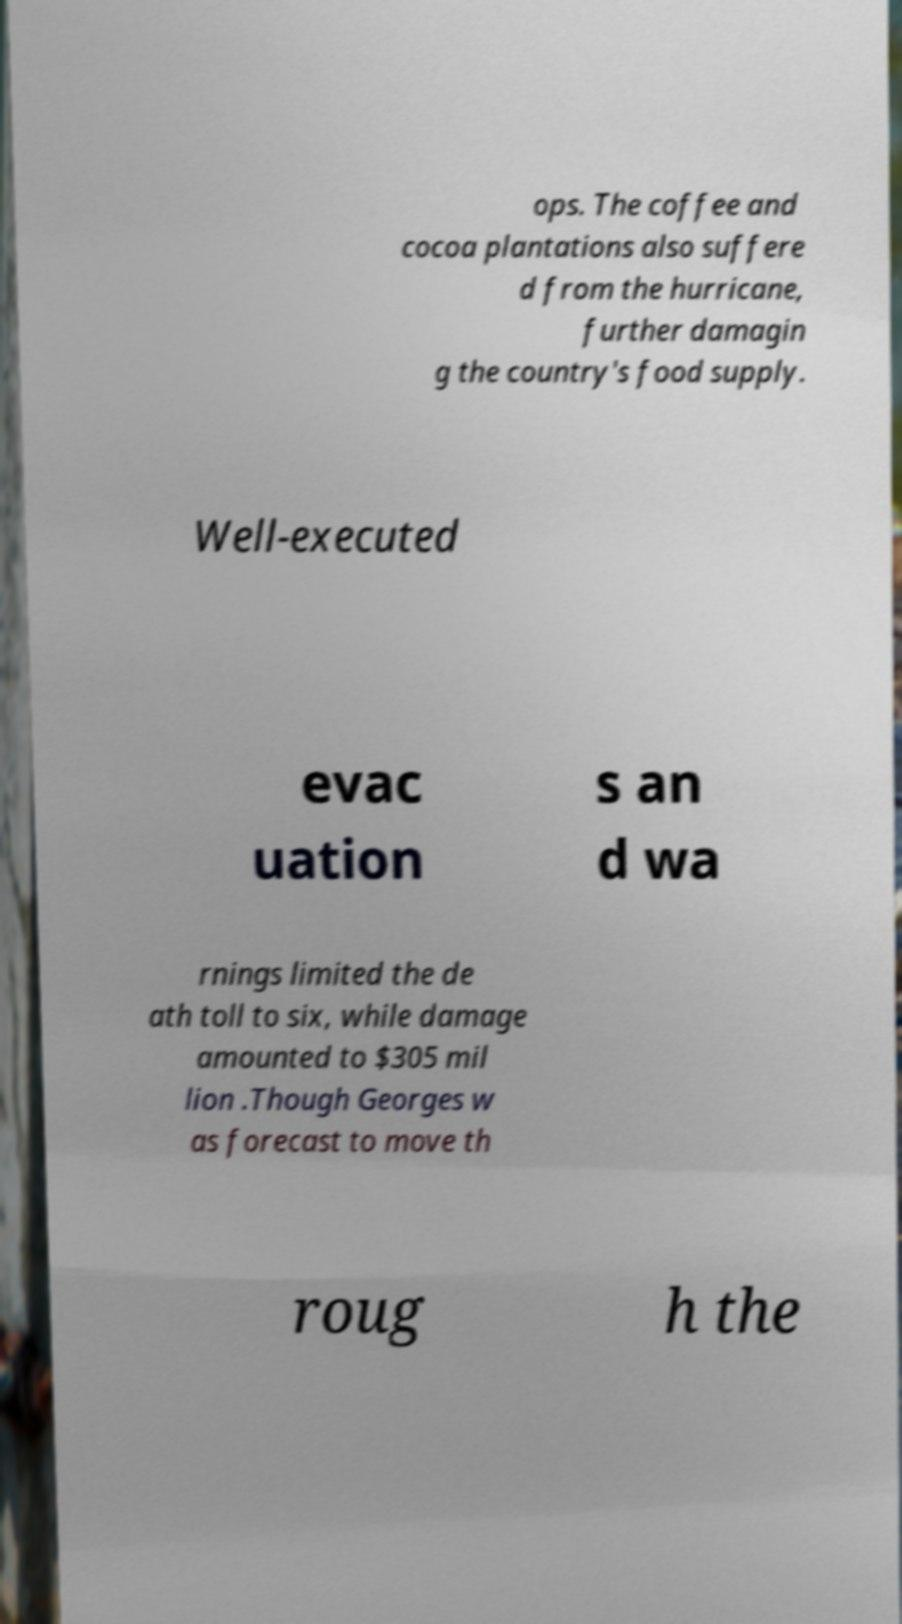Could you extract and type out the text from this image? ops. The coffee and cocoa plantations also suffere d from the hurricane, further damagin g the country's food supply. Well-executed evac uation s an d wa rnings limited the de ath toll to six, while damage amounted to $305 mil lion .Though Georges w as forecast to move th roug h the 